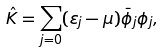<formula> <loc_0><loc_0><loc_500><loc_500>\hat { K } = \sum _ { j = 0 } ( \varepsilon _ { j } - \mu ) \bar { \phi } _ { j } \phi _ { j } ,</formula> 